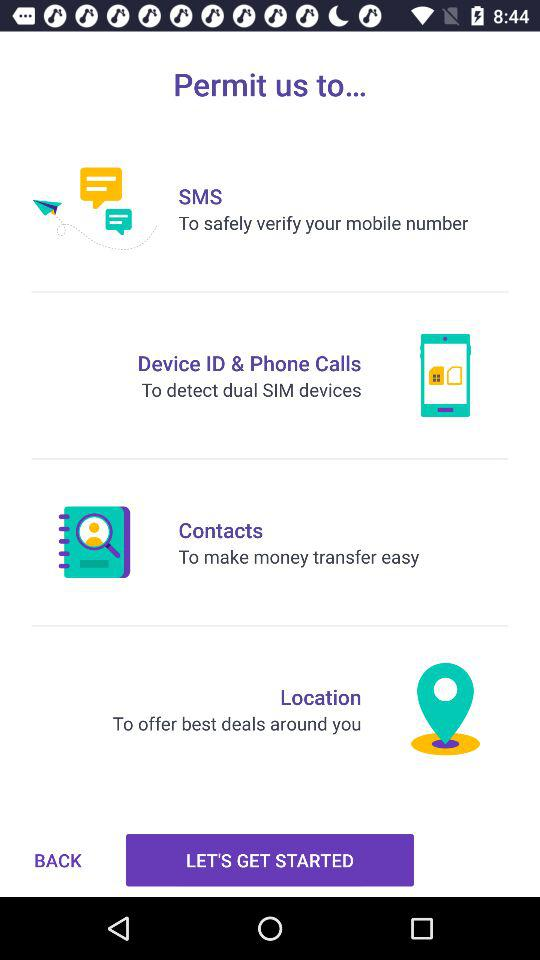How many permission do I need to grant?
Answer the question using a single word or phrase. 4 